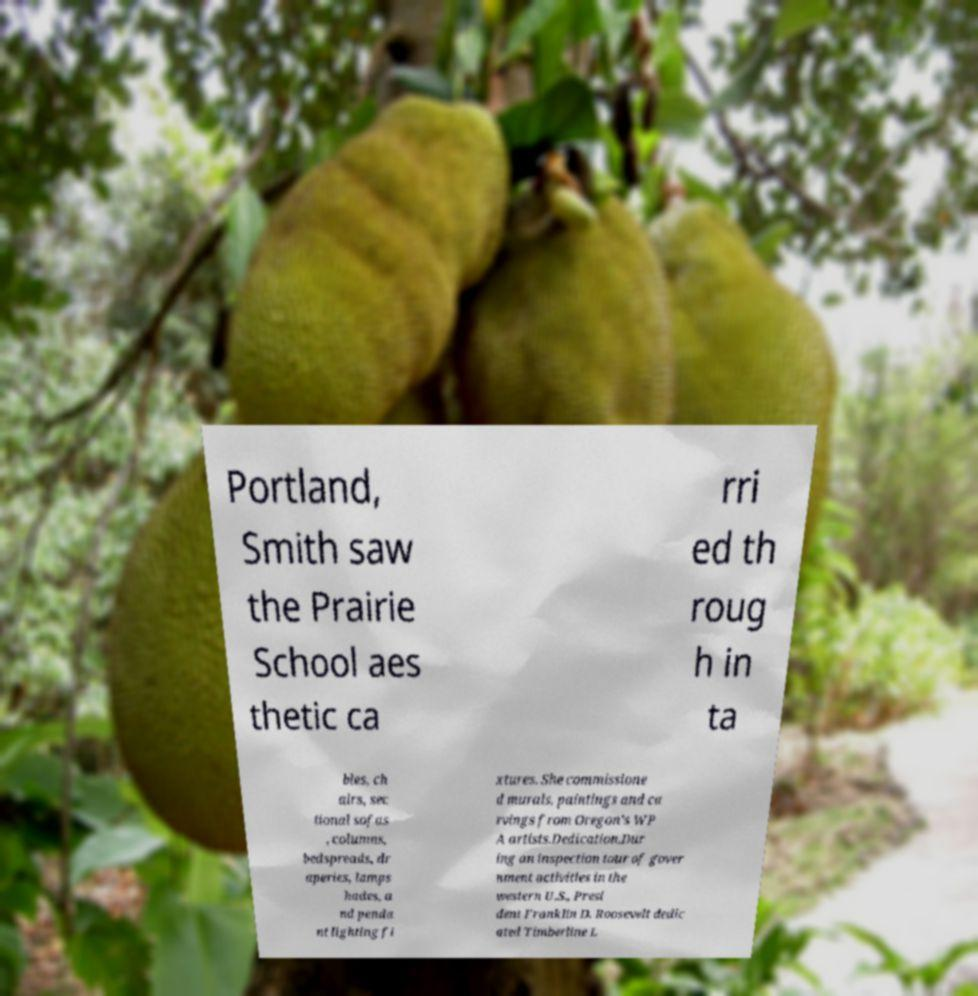Could you extract and type out the text from this image? Portland, Smith saw the Prairie School aes thetic ca rri ed th roug h in ta bles, ch airs, sec tional sofas , columns, bedspreads, dr aperies, lamps hades, a nd penda nt lighting fi xtures. She commissione d murals, paintings and ca rvings from Oregon's WP A artists.Dedication.Dur ing an inspection tour of gover nment activities in the western U.S., Presi dent Franklin D. Roosevelt dedic ated Timberline L 